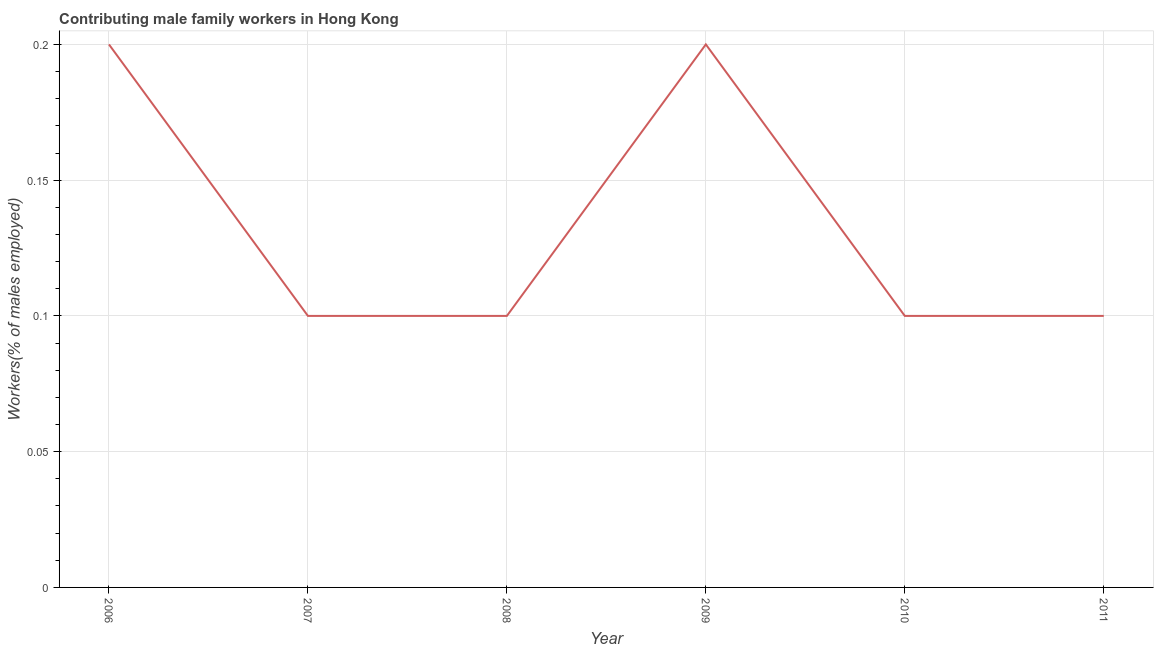What is the contributing male family workers in 2011?
Provide a short and direct response. 0.1. Across all years, what is the maximum contributing male family workers?
Give a very brief answer. 0.2. Across all years, what is the minimum contributing male family workers?
Offer a terse response. 0.1. In which year was the contributing male family workers maximum?
Your answer should be very brief. 2006. In which year was the contributing male family workers minimum?
Your answer should be compact. 2007. What is the sum of the contributing male family workers?
Ensure brevity in your answer.  0.8. What is the difference between the contributing male family workers in 2009 and 2011?
Offer a terse response. 0.1. What is the average contributing male family workers per year?
Offer a very short reply. 0.13. What is the median contributing male family workers?
Provide a short and direct response. 0.1. In how many years, is the contributing male family workers greater than 0.18000000000000002 %?
Ensure brevity in your answer.  2. Do a majority of the years between 2010 and 2006 (inclusive) have contributing male family workers greater than 0.05 %?
Provide a succinct answer. Yes. What is the ratio of the contributing male family workers in 2006 to that in 2008?
Your response must be concise. 2. What is the difference between the highest and the second highest contributing male family workers?
Your answer should be compact. 0. What is the difference between the highest and the lowest contributing male family workers?
Ensure brevity in your answer.  0.1. In how many years, is the contributing male family workers greater than the average contributing male family workers taken over all years?
Make the answer very short. 2. How many lines are there?
Your response must be concise. 1. Are the values on the major ticks of Y-axis written in scientific E-notation?
Your response must be concise. No. Does the graph contain grids?
Ensure brevity in your answer.  Yes. What is the title of the graph?
Keep it short and to the point. Contributing male family workers in Hong Kong. What is the label or title of the X-axis?
Provide a succinct answer. Year. What is the label or title of the Y-axis?
Your answer should be very brief. Workers(% of males employed). What is the Workers(% of males employed) of 2006?
Your answer should be compact. 0.2. What is the Workers(% of males employed) in 2007?
Your answer should be very brief. 0.1. What is the Workers(% of males employed) of 2008?
Make the answer very short. 0.1. What is the Workers(% of males employed) in 2009?
Provide a short and direct response. 0.2. What is the Workers(% of males employed) of 2010?
Offer a terse response. 0.1. What is the Workers(% of males employed) of 2011?
Your answer should be compact. 0.1. What is the difference between the Workers(% of males employed) in 2006 and 2007?
Offer a very short reply. 0.1. What is the difference between the Workers(% of males employed) in 2006 and 2008?
Your answer should be compact. 0.1. What is the difference between the Workers(% of males employed) in 2006 and 2009?
Ensure brevity in your answer.  0. What is the difference between the Workers(% of males employed) in 2007 and 2008?
Provide a succinct answer. 0. What is the difference between the Workers(% of males employed) in 2007 and 2010?
Your response must be concise. 0. What is the difference between the Workers(% of males employed) in 2008 and 2009?
Make the answer very short. -0.1. What is the difference between the Workers(% of males employed) in 2008 and 2010?
Make the answer very short. 0. What is the difference between the Workers(% of males employed) in 2009 and 2011?
Make the answer very short. 0.1. What is the difference between the Workers(% of males employed) in 2010 and 2011?
Your answer should be very brief. 0. What is the ratio of the Workers(% of males employed) in 2006 to that in 2007?
Offer a very short reply. 2. What is the ratio of the Workers(% of males employed) in 2007 to that in 2009?
Your answer should be compact. 0.5. What is the ratio of the Workers(% of males employed) in 2008 to that in 2010?
Give a very brief answer. 1. What is the ratio of the Workers(% of males employed) in 2008 to that in 2011?
Keep it short and to the point. 1. 